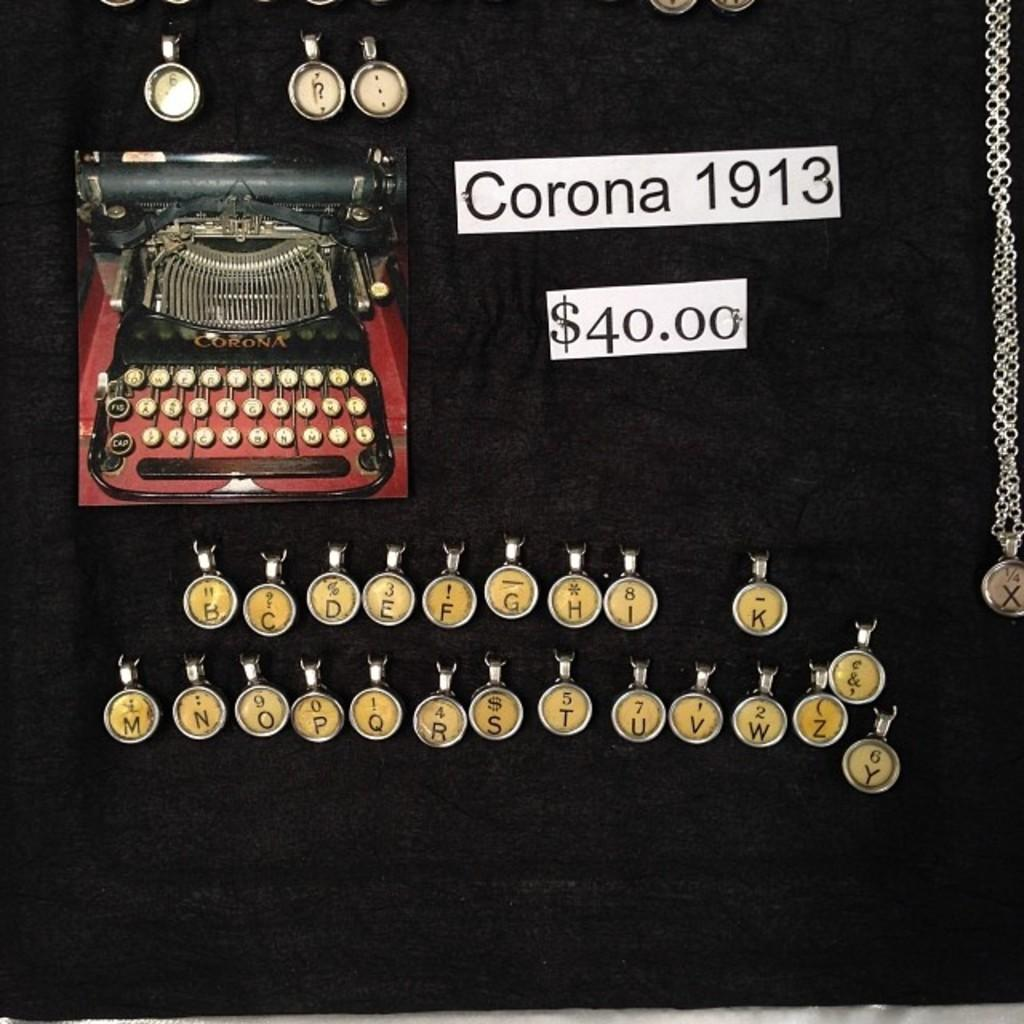What is the primary color of the surface in the image? The image contains a black surface. What object is placed on the black surface? There is a typewriter on the black surface. What feature of the typewriter is mentioned in the facts? The typewriter has keys with letters. What else can be seen in the image besides the typewriter? There is a chain and papers with text and numbers in the image. What type of square can be seen on the typewriter in the image? There is no square present on the typewriter in the image. 